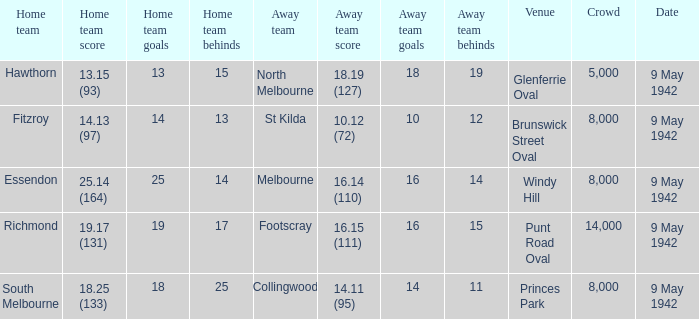How many people attended the game where Footscray was away? 14000.0. 